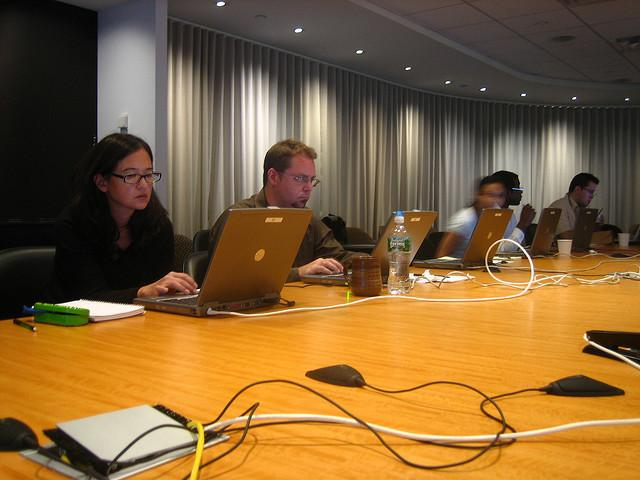What are the people doing in this venue?

Choices:
A) studying
B) watching video
C) working
D) playing game working 